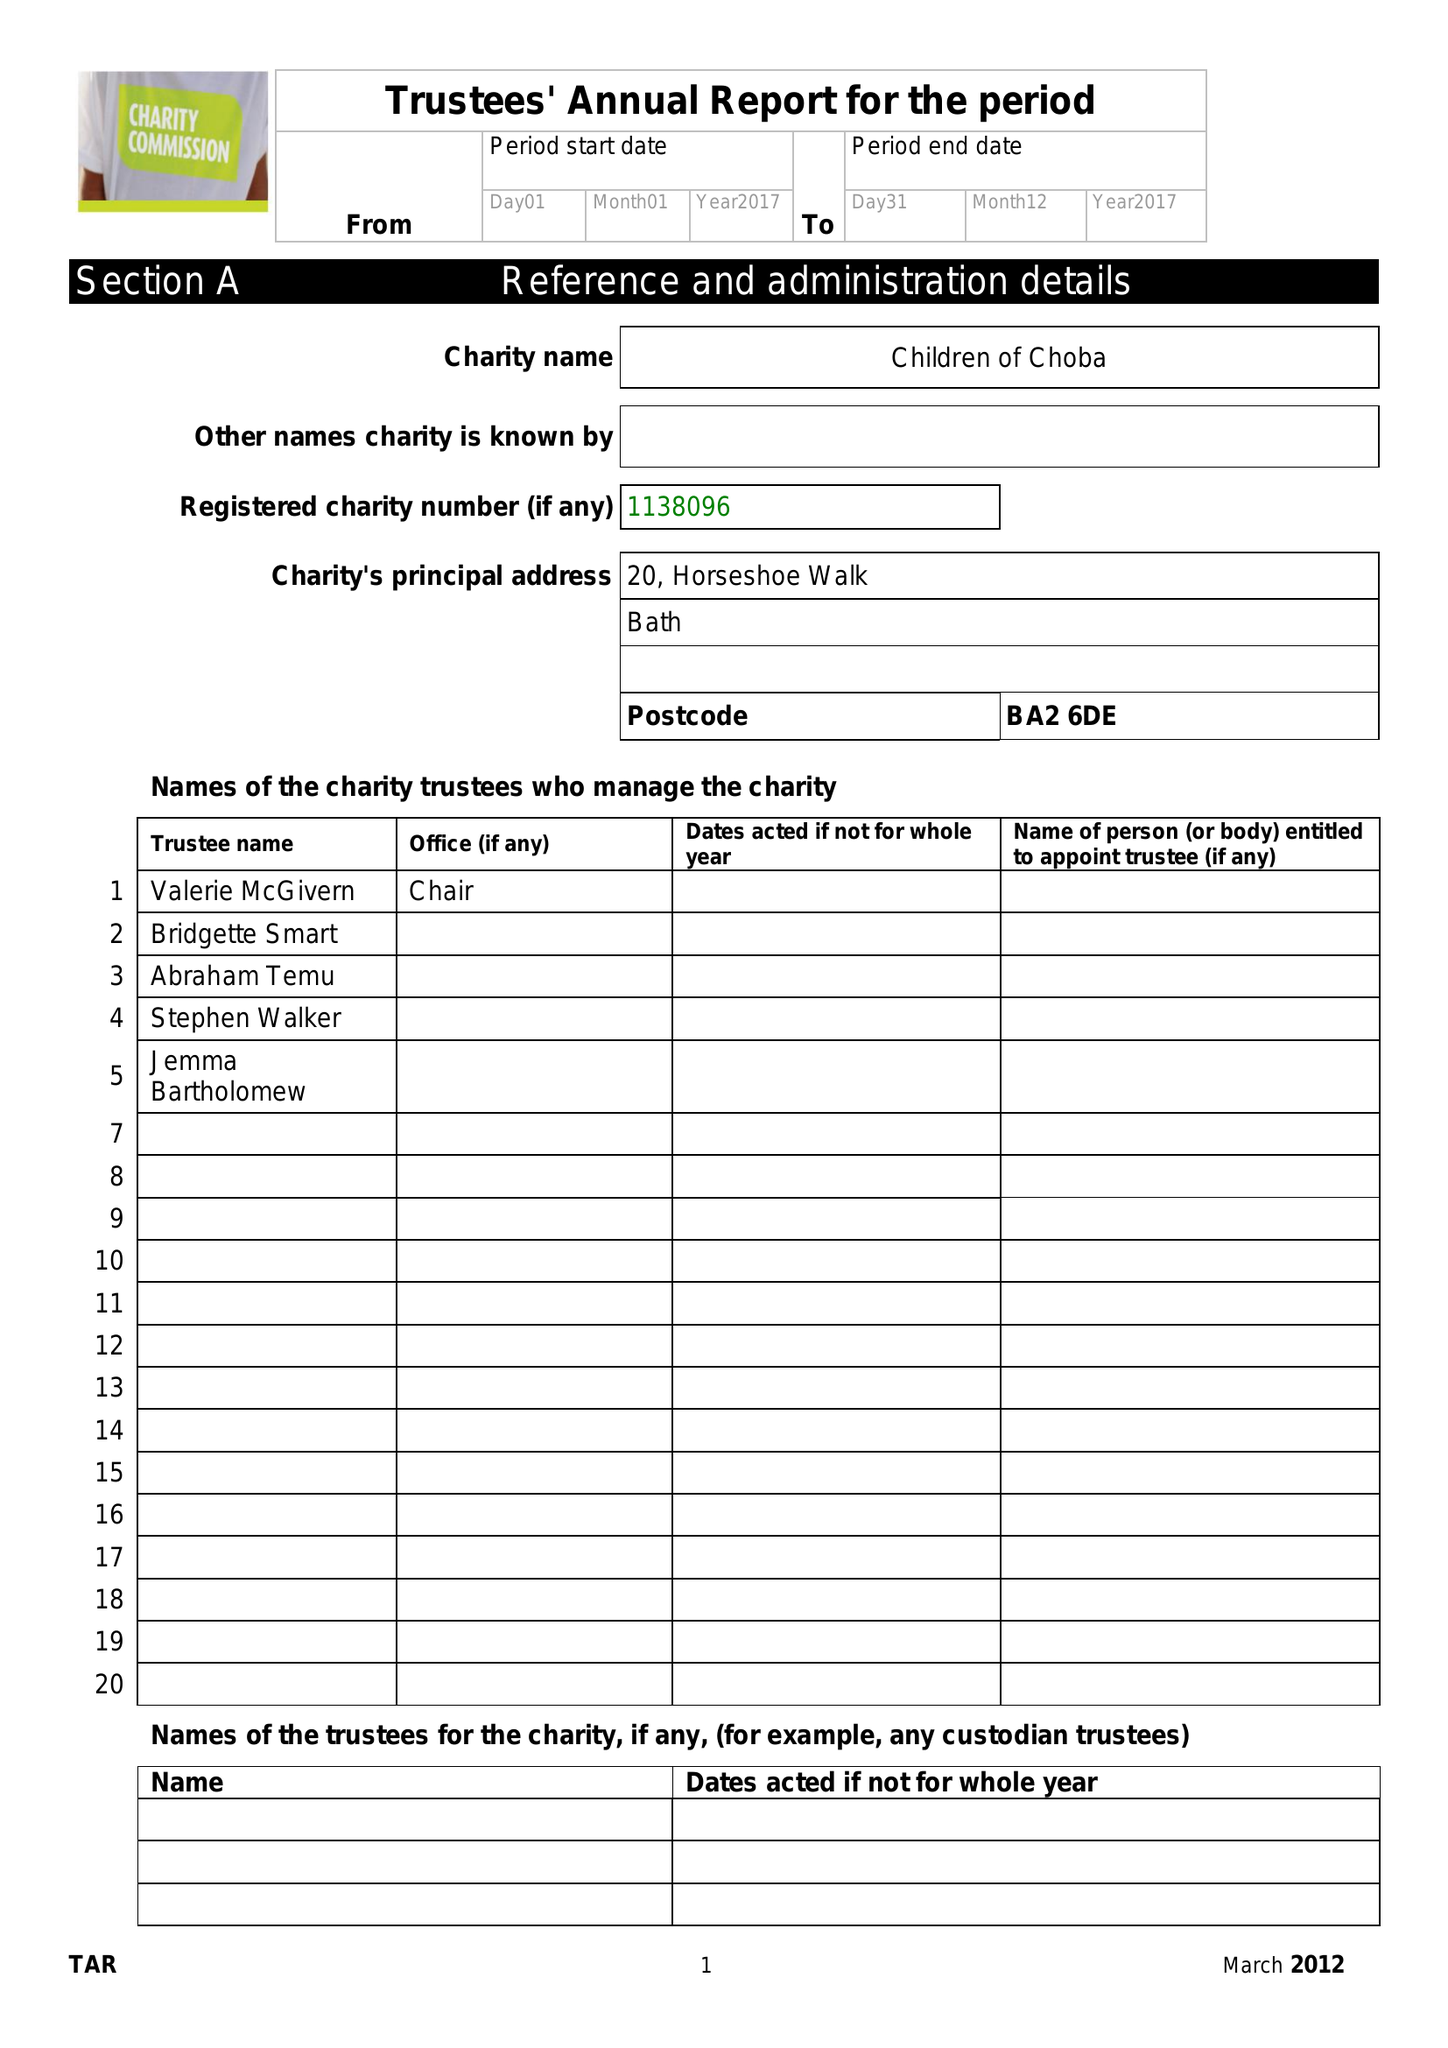What is the value for the spending_annually_in_british_pounds?
Answer the question using a single word or phrase. 63288.00 